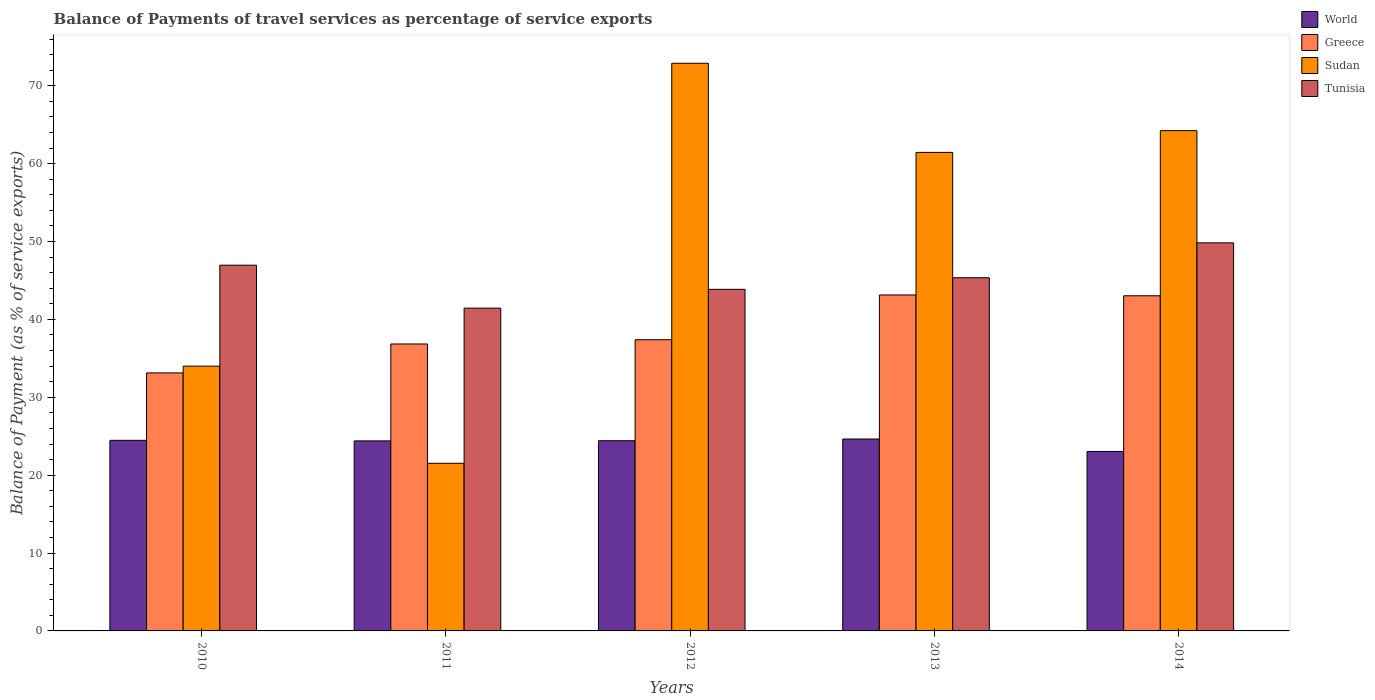In how many cases, is the number of bars for a given year not equal to the number of legend labels?
Provide a succinct answer. 0. What is the balance of payments of travel services in World in 2013?
Offer a terse response. 24.64. Across all years, what is the maximum balance of payments of travel services in World?
Give a very brief answer. 24.64. Across all years, what is the minimum balance of payments of travel services in Sudan?
Offer a very short reply. 21.53. In which year was the balance of payments of travel services in Tunisia maximum?
Provide a succinct answer. 2014. In which year was the balance of payments of travel services in Greece minimum?
Your response must be concise. 2010. What is the total balance of payments of travel services in Tunisia in the graph?
Give a very brief answer. 227.46. What is the difference between the balance of payments of travel services in Greece in 2011 and that in 2014?
Offer a very short reply. -6.19. What is the difference between the balance of payments of travel services in World in 2011 and the balance of payments of travel services in Sudan in 2010?
Offer a terse response. -9.6. What is the average balance of payments of travel services in Greece per year?
Provide a succinct answer. 38.71. In the year 2010, what is the difference between the balance of payments of travel services in Sudan and balance of payments of travel services in Tunisia?
Your response must be concise. -12.96. In how many years, is the balance of payments of travel services in Sudan greater than 48 %?
Provide a short and direct response. 3. What is the ratio of the balance of payments of travel services in Sudan in 2012 to that in 2013?
Ensure brevity in your answer.  1.19. What is the difference between the highest and the second highest balance of payments of travel services in Tunisia?
Ensure brevity in your answer.  2.87. What is the difference between the highest and the lowest balance of payments of travel services in Sudan?
Give a very brief answer. 51.37. In how many years, is the balance of payments of travel services in Greece greater than the average balance of payments of travel services in Greece taken over all years?
Offer a very short reply. 2. Is the sum of the balance of payments of travel services in World in 2011 and 2013 greater than the maximum balance of payments of travel services in Greece across all years?
Your answer should be compact. Yes. What does the 1st bar from the left in 2011 represents?
Ensure brevity in your answer.  World. What does the 2nd bar from the right in 2011 represents?
Ensure brevity in your answer.  Sudan. Is it the case that in every year, the sum of the balance of payments of travel services in Sudan and balance of payments of travel services in Tunisia is greater than the balance of payments of travel services in Greece?
Make the answer very short. Yes. How many bars are there?
Your answer should be compact. 20. Are all the bars in the graph horizontal?
Provide a short and direct response. No. How many years are there in the graph?
Your response must be concise. 5. What is the difference between two consecutive major ticks on the Y-axis?
Your answer should be very brief. 10. What is the title of the graph?
Provide a short and direct response. Balance of Payments of travel services as percentage of service exports. Does "Kosovo" appear as one of the legend labels in the graph?
Ensure brevity in your answer.  No. What is the label or title of the X-axis?
Offer a very short reply. Years. What is the label or title of the Y-axis?
Your response must be concise. Balance of Payment (as % of service exports). What is the Balance of Payment (as % of service exports) of World in 2010?
Offer a terse response. 24.47. What is the Balance of Payment (as % of service exports) of Greece in 2010?
Your response must be concise. 33.13. What is the Balance of Payment (as % of service exports) of Sudan in 2010?
Your answer should be compact. 34. What is the Balance of Payment (as % of service exports) in Tunisia in 2010?
Provide a short and direct response. 46.96. What is the Balance of Payment (as % of service exports) of World in 2011?
Offer a terse response. 24.4. What is the Balance of Payment (as % of service exports) of Greece in 2011?
Offer a very short reply. 36.85. What is the Balance of Payment (as % of service exports) of Sudan in 2011?
Your answer should be very brief. 21.53. What is the Balance of Payment (as % of service exports) of Tunisia in 2011?
Provide a succinct answer. 41.45. What is the Balance of Payment (as % of service exports) in World in 2012?
Your answer should be compact. 24.42. What is the Balance of Payment (as % of service exports) in Greece in 2012?
Make the answer very short. 37.39. What is the Balance of Payment (as % of service exports) of Sudan in 2012?
Provide a short and direct response. 72.89. What is the Balance of Payment (as % of service exports) in Tunisia in 2012?
Your answer should be compact. 43.86. What is the Balance of Payment (as % of service exports) of World in 2013?
Give a very brief answer. 24.64. What is the Balance of Payment (as % of service exports) of Greece in 2013?
Give a very brief answer. 43.14. What is the Balance of Payment (as % of service exports) of Sudan in 2013?
Your response must be concise. 61.45. What is the Balance of Payment (as % of service exports) in Tunisia in 2013?
Provide a short and direct response. 45.35. What is the Balance of Payment (as % of service exports) in World in 2014?
Give a very brief answer. 23.05. What is the Balance of Payment (as % of service exports) in Greece in 2014?
Offer a terse response. 43.04. What is the Balance of Payment (as % of service exports) in Sudan in 2014?
Offer a very short reply. 64.24. What is the Balance of Payment (as % of service exports) of Tunisia in 2014?
Your answer should be compact. 49.83. Across all years, what is the maximum Balance of Payment (as % of service exports) of World?
Make the answer very short. 24.64. Across all years, what is the maximum Balance of Payment (as % of service exports) of Greece?
Provide a succinct answer. 43.14. Across all years, what is the maximum Balance of Payment (as % of service exports) of Sudan?
Offer a very short reply. 72.89. Across all years, what is the maximum Balance of Payment (as % of service exports) in Tunisia?
Your answer should be compact. 49.83. Across all years, what is the minimum Balance of Payment (as % of service exports) of World?
Offer a very short reply. 23.05. Across all years, what is the minimum Balance of Payment (as % of service exports) in Greece?
Your answer should be compact. 33.13. Across all years, what is the minimum Balance of Payment (as % of service exports) in Sudan?
Ensure brevity in your answer.  21.53. Across all years, what is the minimum Balance of Payment (as % of service exports) in Tunisia?
Keep it short and to the point. 41.45. What is the total Balance of Payment (as % of service exports) in World in the graph?
Your response must be concise. 120.99. What is the total Balance of Payment (as % of service exports) of Greece in the graph?
Provide a short and direct response. 193.55. What is the total Balance of Payment (as % of service exports) of Sudan in the graph?
Make the answer very short. 254.11. What is the total Balance of Payment (as % of service exports) in Tunisia in the graph?
Provide a short and direct response. 227.46. What is the difference between the Balance of Payment (as % of service exports) in World in 2010 and that in 2011?
Provide a short and direct response. 0.07. What is the difference between the Balance of Payment (as % of service exports) of Greece in 2010 and that in 2011?
Offer a terse response. -3.72. What is the difference between the Balance of Payment (as % of service exports) of Sudan in 2010 and that in 2011?
Provide a short and direct response. 12.47. What is the difference between the Balance of Payment (as % of service exports) in Tunisia in 2010 and that in 2011?
Keep it short and to the point. 5.51. What is the difference between the Balance of Payment (as % of service exports) of World in 2010 and that in 2012?
Provide a short and direct response. 0.05. What is the difference between the Balance of Payment (as % of service exports) of Greece in 2010 and that in 2012?
Provide a succinct answer. -4.26. What is the difference between the Balance of Payment (as % of service exports) in Sudan in 2010 and that in 2012?
Offer a terse response. -38.89. What is the difference between the Balance of Payment (as % of service exports) of Tunisia in 2010 and that in 2012?
Provide a succinct answer. 3.1. What is the difference between the Balance of Payment (as % of service exports) of World in 2010 and that in 2013?
Your response must be concise. -0.17. What is the difference between the Balance of Payment (as % of service exports) of Greece in 2010 and that in 2013?
Make the answer very short. -10.01. What is the difference between the Balance of Payment (as % of service exports) of Sudan in 2010 and that in 2013?
Ensure brevity in your answer.  -27.45. What is the difference between the Balance of Payment (as % of service exports) of Tunisia in 2010 and that in 2013?
Make the answer very short. 1.61. What is the difference between the Balance of Payment (as % of service exports) in World in 2010 and that in 2014?
Keep it short and to the point. 1.43. What is the difference between the Balance of Payment (as % of service exports) of Greece in 2010 and that in 2014?
Keep it short and to the point. -9.91. What is the difference between the Balance of Payment (as % of service exports) in Sudan in 2010 and that in 2014?
Provide a succinct answer. -30.24. What is the difference between the Balance of Payment (as % of service exports) of Tunisia in 2010 and that in 2014?
Give a very brief answer. -2.87. What is the difference between the Balance of Payment (as % of service exports) of World in 2011 and that in 2012?
Provide a succinct answer. -0.02. What is the difference between the Balance of Payment (as % of service exports) in Greece in 2011 and that in 2012?
Your response must be concise. -0.55. What is the difference between the Balance of Payment (as % of service exports) in Sudan in 2011 and that in 2012?
Make the answer very short. -51.37. What is the difference between the Balance of Payment (as % of service exports) of Tunisia in 2011 and that in 2012?
Offer a terse response. -2.41. What is the difference between the Balance of Payment (as % of service exports) of World in 2011 and that in 2013?
Ensure brevity in your answer.  -0.24. What is the difference between the Balance of Payment (as % of service exports) of Greece in 2011 and that in 2013?
Offer a very short reply. -6.3. What is the difference between the Balance of Payment (as % of service exports) of Sudan in 2011 and that in 2013?
Offer a terse response. -39.92. What is the difference between the Balance of Payment (as % of service exports) in Tunisia in 2011 and that in 2013?
Keep it short and to the point. -3.9. What is the difference between the Balance of Payment (as % of service exports) in World in 2011 and that in 2014?
Your response must be concise. 1.35. What is the difference between the Balance of Payment (as % of service exports) of Greece in 2011 and that in 2014?
Make the answer very short. -6.19. What is the difference between the Balance of Payment (as % of service exports) in Sudan in 2011 and that in 2014?
Ensure brevity in your answer.  -42.71. What is the difference between the Balance of Payment (as % of service exports) of Tunisia in 2011 and that in 2014?
Make the answer very short. -8.38. What is the difference between the Balance of Payment (as % of service exports) of World in 2012 and that in 2013?
Ensure brevity in your answer.  -0.22. What is the difference between the Balance of Payment (as % of service exports) of Greece in 2012 and that in 2013?
Provide a succinct answer. -5.75. What is the difference between the Balance of Payment (as % of service exports) of Sudan in 2012 and that in 2013?
Your answer should be compact. 11.45. What is the difference between the Balance of Payment (as % of service exports) of Tunisia in 2012 and that in 2013?
Your response must be concise. -1.49. What is the difference between the Balance of Payment (as % of service exports) of World in 2012 and that in 2014?
Keep it short and to the point. 1.38. What is the difference between the Balance of Payment (as % of service exports) of Greece in 2012 and that in 2014?
Ensure brevity in your answer.  -5.64. What is the difference between the Balance of Payment (as % of service exports) of Sudan in 2012 and that in 2014?
Offer a very short reply. 8.65. What is the difference between the Balance of Payment (as % of service exports) in Tunisia in 2012 and that in 2014?
Your response must be concise. -5.97. What is the difference between the Balance of Payment (as % of service exports) in World in 2013 and that in 2014?
Provide a short and direct response. 1.6. What is the difference between the Balance of Payment (as % of service exports) of Greece in 2013 and that in 2014?
Give a very brief answer. 0.1. What is the difference between the Balance of Payment (as % of service exports) of Sudan in 2013 and that in 2014?
Your answer should be very brief. -2.79. What is the difference between the Balance of Payment (as % of service exports) in Tunisia in 2013 and that in 2014?
Offer a very short reply. -4.48. What is the difference between the Balance of Payment (as % of service exports) of World in 2010 and the Balance of Payment (as % of service exports) of Greece in 2011?
Offer a terse response. -12.37. What is the difference between the Balance of Payment (as % of service exports) in World in 2010 and the Balance of Payment (as % of service exports) in Sudan in 2011?
Give a very brief answer. 2.95. What is the difference between the Balance of Payment (as % of service exports) of World in 2010 and the Balance of Payment (as % of service exports) of Tunisia in 2011?
Your response must be concise. -16.98. What is the difference between the Balance of Payment (as % of service exports) of Greece in 2010 and the Balance of Payment (as % of service exports) of Sudan in 2011?
Provide a short and direct response. 11.6. What is the difference between the Balance of Payment (as % of service exports) of Greece in 2010 and the Balance of Payment (as % of service exports) of Tunisia in 2011?
Offer a terse response. -8.32. What is the difference between the Balance of Payment (as % of service exports) in Sudan in 2010 and the Balance of Payment (as % of service exports) in Tunisia in 2011?
Your response must be concise. -7.45. What is the difference between the Balance of Payment (as % of service exports) of World in 2010 and the Balance of Payment (as % of service exports) of Greece in 2012?
Make the answer very short. -12.92. What is the difference between the Balance of Payment (as % of service exports) of World in 2010 and the Balance of Payment (as % of service exports) of Sudan in 2012?
Ensure brevity in your answer.  -48.42. What is the difference between the Balance of Payment (as % of service exports) in World in 2010 and the Balance of Payment (as % of service exports) in Tunisia in 2012?
Your response must be concise. -19.39. What is the difference between the Balance of Payment (as % of service exports) of Greece in 2010 and the Balance of Payment (as % of service exports) of Sudan in 2012?
Your response must be concise. -39.76. What is the difference between the Balance of Payment (as % of service exports) in Greece in 2010 and the Balance of Payment (as % of service exports) in Tunisia in 2012?
Offer a terse response. -10.73. What is the difference between the Balance of Payment (as % of service exports) of Sudan in 2010 and the Balance of Payment (as % of service exports) of Tunisia in 2012?
Provide a short and direct response. -9.86. What is the difference between the Balance of Payment (as % of service exports) of World in 2010 and the Balance of Payment (as % of service exports) of Greece in 2013?
Your answer should be compact. -18.67. What is the difference between the Balance of Payment (as % of service exports) of World in 2010 and the Balance of Payment (as % of service exports) of Sudan in 2013?
Provide a succinct answer. -36.97. What is the difference between the Balance of Payment (as % of service exports) of World in 2010 and the Balance of Payment (as % of service exports) of Tunisia in 2013?
Offer a very short reply. -20.88. What is the difference between the Balance of Payment (as % of service exports) in Greece in 2010 and the Balance of Payment (as % of service exports) in Sudan in 2013?
Offer a very short reply. -28.32. What is the difference between the Balance of Payment (as % of service exports) in Greece in 2010 and the Balance of Payment (as % of service exports) in Tunisia in 2013?
Your answer should be compact. -12.22. What is the difference between the Balance of Payment (as % of service exports) in Sudan in 2010 and the Balance of Payment (as % of service exports) in Tunisia in 2013?
Your answer should be very brief. -11.35. What is the difference between the Balance of Payment (as % of service exports) in World in 2010 and the Balance of Payment (as % of service exports) in Greece in 2014?
Provide a succinct answer. -18.56. What is the difference between the Balance of Payment (as % of service exports) in World in 2010 and the Balance of Payment (as % of service exports) in Sudan in 2014?
Ensure brevity in your answer.  -39.77. What is the difference between the Balance of Payment (as % of service exports) of World in 2010 and the Balance of Payment (as % of service exports) of Tunisia in 2014?
Provide a short and direct response. -25.36. What is the difference between the Balance of Payment (as % of service exports) of Greece in 2010 and the Balance of Payment (as % of service exports) of Sudan in 2014?
Offer a terse response. -31.11. What is the difference between the Balance of Payment (as % of service exports) of Greece in 2010 and the Balance of Payment (as % of service exports) of Tunisia in 2014?
Provide a succinct answer. -16.7. What is the difference between the Balance of Payment (as % of service exports) of Sudan in 2010 and the Balance of Payment (as % of service exports) of Tunisia in 2014?
Your answer should be very brief. -15.83. What is the difference between the Balance of Payment (as % of service exports) in World in 2011 and the Balance of Payment (as % of service exports) in Greece in 2012?
Offer a terse response. -12.99. What is the difference between the Balance of Payment (as % of service exports) in World in 2011 and the Balance of Payment (as % of service exports) in Sudan in 2012?
Your answer should be compact. -48.49. What is the difference between the Balance of Payment (as % of service exports) in World in 2011 and the Balance of Payment (as % of service exports) in Tunisia in 2012?
Provide a short and direct response. -19.46. What is the difference between the Balance of Payment (as % of service exports) in Greece in 2011 and the Balance of Payment (as % of service exports) in Sudan in 2012?
Offer a very short reply. -36.05. What is the difference between the Balance of Payment (as % of service exports) of Greece in 2011 and the Balance of Payment (as % of service exports) of Tunisia in 2012?
Offer a very short reply. -7.02. What is the difference between the Balance of Payment (as % of service exports) of Sudan in 2011 and the Balance of Payment (as % of service exports) of Tunisia in 2012?
Offer a terse response. -22.34. What is the difference between the Balance of Payment (as % of service exports) of World in 2011 and the Balance of Payment (as % of service exports) of Greece in 2013?
Provide a short and direct response. -18.74. What is the difference between the Balance of Payment (as % of service exports) of World in 2011 and the Balance of Payment (as % of service exports) of Sudan in 2013?
Ensure brevity in your answer.  -37.05. What is the difference between the Balance of Payment (as % of service exports) in World in 2011 and the Balance of Payment (as % of service exports) in Tunisia in 2013?
Make the answer very short. -20.95. What is the difference between the Balance of Payment (as % of service exports) in Greece in 2011 and the Balance of Payment (as % of service exports) in Sudan in 2013?
Give a very brief answer. -24.6. What is the difference between the Balance of Payment (as % of service exports) of Greece in 2011 and the Balance of Payment (as % of service exports) of Tunisia in 2013?
Provide a succinct answer. -8.51. What is the difference between the Balance of Payment (as % of service exports) in Sudan in 2011 and the Balance of Payment (as % of service exports) in Tunisia in 2013?
Keep it short and to the point. -23.83. What is the difference between the Balance of Payment (as % of service exports) in World in 2011 and the Balance of Payment (as % of service exports) in Greece in 2014?
Make the answer very short. -18.63. What is the difference between the Balance of Payment (as % of service exports) in World in 2011 and the Balance of Payment (as % of service exports) in Sudan in 2014?
Your response must be concise. -39.84. What is the difference between the Balance of Payment (as % of service exports) of World in 2011 and the Balance of Payment (as % of service exports) of Tunisia in 2014?
Provide a succinct answer. -25.43. What is the difference between the Balance of Payment (as % of service exports) in Greece in 2011 and the Balance of Payment (as % of service exports) in Sudan in 2014?
Make the answer very short. -27.39. What is the difference between the Balance of Payment (as % of service exports) in Greece in 2011 and the Balance of Payment (as % of service exports) in Tunisia in 2014?
Provide a succinct answer. -12.98. What is the difference between the Balance of Payment (as % of service exports) in Sudan in 2011 and the Balance of Payment (as % of service exports) in Tunisia in 2014?
Your answer should be compact. -28.3. What is the difference between the Balance of Payment (as % of service exports) of World in 2012 and the Balance of Payment (as % of service exports) of Greece in 2013?
Your answer should be very brief. -18.72. What is the difference between the Balance of Payment (as % of service exports) in World in 2012 and the Balance of Payment (as % of service exports) in Sudan in 2013?
Offer a very short reply. -37.02. What is the difference between the Balance of Payment (as % of service exports) of World in 2012 and the Balance of Payment (as % of service exports) of Tunisia in 2013?
Offer a terse response. -20.93. What is the difference between the Balance of Payment (as % of service exports) of Greece in 2012 and the Balance of Payment (as % of service exports) of Sudan in 2013?
Offer a terse response. -24.05. What is the difference between the Balance of Payment (as % of service exports) of Greece in 2012 and the Balance of Payment (as % of service exports) of Tunisia in 2013?
Provide a short and direct response. -7.96. What is the difference between the Balance of Payment (as % of service exports) of Sudan in 2012 and the Balance of Payment (as % of service exports) of Tunisia in 2013?
Your answer should be compact. 27.54. What is the difference between the Balance of Payment (as % of service exports) in World in 2012 and the Balance of Payment (as % of service exports) in Greece in 2014?
Offer a very short reply. -18.61. What is the difference between the Balance of Payment (as % of service exports) in World in 2012 and the Balance of Payment (as % of service exports) in Sudan in 2014?
Offer a very short reply. -39.82. What is the difference between the Balance of Payment (as % of service exports) in World in 2012 and the Balance of Payment (as % of service exports) in Tunisia in 2014?
Keep it short and to the point. -25.41. What is the difference between the Balance of Payment (as % of service exports) in Greece in 2012 and the Balance of Payment (as % of service exports) in Sudan in 2014?
Keep it short and to the point. -26.85. What is the difference between the Balance of Payment (as % of service exports) in Greece in 2012 and the Balance of Payment (as % of service exports) in Tunisia in 2014?
Your answer should be compact. -12.44. What is the difference between the Balance of Payment (as % of service exports) of Sudan in 2012 and the Balance of Payment (as % of service exports) of Tunisia in 2014?
Your response must be concise. 23.06. What is the difference between the Balance of Payment (as % of service exports) in World in 2013 and the Balance of Payment (as % of service exports) in Greece in 2014?
Give a very brief answer. -18.39. What is the difference between the Balance of Payment (as % of service exports) in World in 2013 and the Balance of Payment (as % of service exports) in Sudan in 2014?
Give a very brief answer. -39.6. What is the difference between the Balance of Payment (as % of service exports) in World in 2013 and the Balance of Payment (as % of service exports) in Tunisia in 2014?
Offer a very short reply. -25.19. What is the difference between the Balance of Payment (as % of service exports) in Greece in 2013 and the Balance of Payment (as % of service exports) in Sudan in 2014?
Make the answer very short. -21.1. What is the difference between the Balance of Payment (as % of service exports) of Greece in 2013 and the Balance of Payment (as % of service exports) of Tunisia in 2014?
Your answer should be compact. -6.69. What is the difference between the Balance of Payment (as % of service exports) of Sudan in 2013 and the Balance of Payment (as % of service exports) of Tunisia in 2014?
Give a very brief answer. 11.62. What is the average Balance of Payment (as % of service exports) of World per year?
Your response must be concise. 24.2. What is the average Balance of Payment (as % of service exports) of Greece per year?
Provide a succinct answer. 38.71. What is the average Balance of Payment (as % of service exports) in Sudan per year?
Your answer should be compact. 50.82. What is the average Balance of Payment (as % of service exports) in Tunisia per year?
Your answer should be very brief. 45.49. In the year 2010, what is the difference between the Balance of Payment (as % of service exports) in World and Balance of Payment (as % of service exports) in Greece?
Provide a succinct answer. -8.66. In the year 2010, what is the difference between the Balance of Payment (as % of service exports) of World and Balance of Payment (as % of service exports) of Sudan?
Your response must be concise. -9.53. In the year 2010, what is the difference between the Balance of Payment (as % of service exports) in World and Balance of Payment (as % of service exports) in Tunisia?
Your response must be concise. -22.49. In the year 2010, what is the difference between the Balance of Payment (as % of service exports) of Greece and Balance of Payment (as % of service exports) of Sudan?
Provide a short and direct response. -0.87. In the year 2010, what is the difference between the Balance of Payment (as % of service exports) in Greece and Balance of Payment (as % of service exports) in Tunisia?
Offer a terse response. -13.83. In the year 2010, what is the difference between the Balance of Payment (as % of service exports) of Sudan and Balance of Payment (as % of service exports) of Tunisia?
Offer a terse response. -12.96. In the year 2011, what is the difference between the Balance of Payment (as % of service exports) of World and Balance of Payment (as % of service exports) of Greece?
Ensure brevity in your answer.  -12.44. In the year 2011, what is the difference between the Balance of Payment (as % of service exports) in World and Balance of Payment (as % of service exports) in Sudan?
Keep it short and to the point. 2.88. In the year 2011, what is the difference between the Balance of Payment (as % of service exports) in World and Balance of Payment (as % of service exports) in Tunisia?
Your answer should be compact. -17.05. In the year 2011, what is the difference between the Balance of Payment (as % of service exports) in Greece and Balance of Payment (as % of service exports) in Sudan?
Offer a terse response. 15.32. In the year 2011, what is the difference between the Balance of Payment (as % of service exports) of Greece and Balance of Payment (as % of service exports) of Tunisia?
Offer a terse response. -4.6. In the year 2011, what is the difference between the Balance of Payment (as % of service exports) of Sudan and Balance of Payment (as % of service exports) of Tunisia?
Your answer should be very brief. -19.92. In the year 2012, what is the difference between the Balance of Payment (as % of service exports) in World and Balance of Payment (as % of service exports) in Greece?
Give a very brief answer. -12.97. In the year 2012, what is the difference between the Balance of Payment (as % of service exports) of World and Balance of Payment (as % of service exports) of Sudan?
Offer a very short reply. -48.47. In the year 2012, what is the difference between the Balance of Payment (as % of service exports) in World and Balance of Payment (as % of service exports) in Tunisia?
Offer a terse response. -19.44. In the year 2012, what is the difference between the Balance of Payment (as % of service exports) in Greece and Balance of Payment (as % of service exports) in Sudan?
Provide a succinct answer. -35.5. In the year 2012, what is the difference between the Balance of Payment (as % of service exports) in Greece and Balance of Payment (as % of service exports) in Tunisia?
Your answer should be compact. -6.47. In the year 2012, what is the difference between the Balance of Payment (as % of service exports) of Sudan and Balance of Payment (as % of service exports) of Tunisia?
Your response must be concise. 29.03. In the year 2013, what is the difference between the Balance of Payment (as % of service exports) of World and Balance of Payment (as % of service exports) of Greece?
Your answer should be compact. -18.5. In the year 2013, what is the difference between the Balance of Payment (as % of service exports) of World and Balance of Payment (as % of service exports) of Sudan?
Provide a succinct answer. -36.8. In the year 2013, what is the difference between the Balance of Payment (as % of service exports) in World and Balance of Payment (as % of service exports) in Tunisia?
Give a very brief answer. -20.71. In the year 2013, what is the difference between the Balance of Payment (as % of service exports) in Greece and Balance of Payment (as % of service exports) in Sudan?
Your answer should be very brief. -18.31. In the year 2013, what is the difference between the Balance of Payment (as % of service exports) in Greece and Balance of Payment (as % of service exports) in Tunisia?
Ensure brevity in your answer.  -2.21. In the year 2013, what is the difference between the Balance of Payment (as % of service exports) in Sudan and Balance of Payment (as % of service exports) in Tunisia?
Give a very brief answer. 16.09. In the year 2014, what is the difference between the Balance of Payment (as % of service exports) of World and Balance of Payment (as % of service exports) of Greece?
Offer a very short reply. -19.99. In the year 2014, what is the difference between the Balance of Payment (as % of service exports) in World and Balance of Payment (as % of service exports) in Sudan?
Offer a very short reply. -41.19. In the year 2014, what is the difference between the Balance of Payment (as % of service exports) in World and Balance of Payment (as % of service exports) in Tunisia?
Keep it short and to the point. -26.78. In the year 2014, what is the difference between the Balance of Payment (as % of service exports) of Greece and Balance of Payment (as % of service exports) of Sudan?
Offer a very short reply. -21.2. In the year 2014, what is the difference between the Balance of Payment (as % of service exports) in Greece and Balance of Payment (as % of service exports) in Tunisia?
Provide a short and direct response. -6.79. In the year 2014, what is the difference between the Balance of Payment (as % of service exports) in Sudan and Balance of Payment (as % of service exports) in Tunisia?
Make the answer very short. 14.41. What is the ratio of the Balance of Payment (as % of service exports) of World in 2010 to that in 2011?
Make the answer very short. 1. What is the ratio of the Balance of Payment (as % of service exports) in Greece in 2010 to that in 2011?
Offer a very short reply. 0.9. What is the ratio of the Balance of Payment (as % of service exports) in Sudan in 2010 to that in 2011?
Provide a succinct answer. 1.58. What is the ratio of the Balance of Payment (as % of service exports) of Tunisia in 2010 to that in 2011?
Your response must be concise. 1.13. What is the ratio of the Balance of Payment (as % of service exports) in Greece in 2010 to that in 2012?
Provide a succinct answer. 0.89. What is the ratio of the Balance of Payment (as % of service exports) of Sudan in 2010 to that in 2012?
Provide a succinct answer. 0.47. What is the ratio of the Balance of Payment (as % of service exports) of Tunisia in 2010 to that in 2012?
Keep it short and to the point. 1.07. What is the ratio of the Balance of Payment (as % of service exports) of World in 2010 to that in 2013?
Offer a terse response. 0.99. What is the ratio of the Balance of Payment (as % of service exports) of Greece in 2010 to that in 2013?
Give a very brief answer. 0.77. What is the ratio of the Balance of Payment (as % of service exports) in Sudan in 2010 to that in 2013?
Ensure brevity in your answer.  0.55. What is the ratio of the Balance of Payment (as % of service exports) of Tunisia in 2010 to that in 2013?
Make the answer very short. 1.04. What is the ratio of the Balance of Payment (as % of service exports) of World in 2010 to that in 2014?
Keep it short and to the point. 1.06. What is the ratio of the Balance of Payment (as % of service exports) in Greece in 2010 to that in 2014?
Provide a short and direct response. 0.77. What is the ratio of the Balance of Payment (as % of service exports) of Sudan in 2010 to that in 2014?
Your answer should be compact. 0.53. What is the ratio of the Balance of Payment (as % of service exports) of Tunisia in 2010 to that in 2014?
Offer a terse response. 0.94. What is the ratio of the Balance of Payment (as % of service exports) of Sudan in 2011 to that in 2012?
Offer a terse response. 0.3. What is the ratio of the Balance of Payment (as % of service exports) in Tunisia in 2011 to that in 2012?
Keep it short and to the point. 0.94. What is the ratio of the Balance of Payment (as % of service exports) in World in 2011 to that in 2013?
Your answer should be very brief. 0.99. What is the ratio of the Balance of Payment (as % of service exports) in Greece in 2011 to that in 2013?
Your response must be concise. 0.85. What is the ratio of the Balance of Payment (as % of service exports) of Sudan in 2011 to that in 2013?
Your answer should be very brief. 0.35. What is the ratio of the Balance of Payment (as % of service exports) in Tunisia in 2011 to that in 2013?
Your answer should be very brief. 0.91. What is the ratio of the Balance of Payment (as % of service exports) of World in 2011 to that in 2014?
Provide a short and direct response. 1.06. What is the ratio of the Balance of Payment (as % of service exports) in Greece in 2011 to that in 2014?
Your response must be concise. 0.86. What is the ratio of the Balance of Payment (as % of service exports) in Sudan in 2011 to that in 2014?
Ensure brevity in your answer.  0.34. What is the ratio of the Balance of Payment (as % of service exports) of Tunisia in 2011 to that in 2014?
Provide a succinct answer. 0.83. What is the ratio of the Balance of Payment (as % of service exports) in Greece in 2012 to that in 2013?
Offer a very short reply. 0.87. What is the ratio of the Balance of Payment (as % of service exports) of Sudan in 2012 to that in 2013?
Your response must be concise. 1.19. What is the ratio of the Balance of Payment (as % of service exports) in Tunisia in 2012 to that in 2013?
Ensure brevity in your answer.  0.97. What is the ratio of the Balance of Payment (as % of service exports) of World in 2012 to that in 2014?
Keep it short and to the point. 1.06. What is the ratio of the Balance of Payment (as % of service exports) of Greece in 2012 to that in 2014?
Make the answer very short. 0.87. What is the ratio of the Balance of Payment (as % of service exports) in Sudan in 2012 to that in 2014?
Make the answer very short. 1.13. What is the ratio of the Balance of Payment (as % of service exports) in Tunisia in 2012 to that in 2014?
Your answer should be very brief. 0.88. What is the ratio of the Balance of Payment (as % of service exports) of World in 2013 to that in 2014?
Your response must be concise. 1.07. What is the ratio of the Balance of Payment (as % of service exports) in Greece in 2013 to that in 2014?
Give a very brief answer. 1. What is the ratio of the Balance of Payment (as % of service exports) in Sudan in 2013 to that in 2014?
Provide a succinct answer. 0.96. What is the ratio of the Balance of Payment (as % of service exports) in Tunisia in 2013 to that in 2014?
Your answer should be compact. 0.91. What is the difference between the highest and the second highest Balance of Payment (as % of service exports) in World?
Offer a very short reply. 0.17. What is the difference between the highest and the second highest Balance of Payment (as % of service exports) in Greece?
Offer a very short reply. 0.1. What is the difference between the highest and the second highest Balance of Payment (as % of service exports) of Sudan?
Your answer should be compact. 8.65. What is the difference between the highest and the second highest Balance of Payment (as % of service exports) of Tunisia?
Offer a very short reply. 2.87. What is the difference between the highest and the lowest Balance of Payment (as % of service exports) in World?
Provide a short and direct response. 1.6. What is the difference between the highest and the lowest Balance of Payment (as % of service exports) of Greece?
Give a very brief answer. 10.01. What is the difference between the highest and the lowest Balance of Payment (as % of service exports) in Sudan?
Your answer should be very brief. 51.37. What is the difference between the highest and the lowest Balance of Payment (as % of service exports) in Tunisia?
Ensure brevity in your answer.  8.38. 